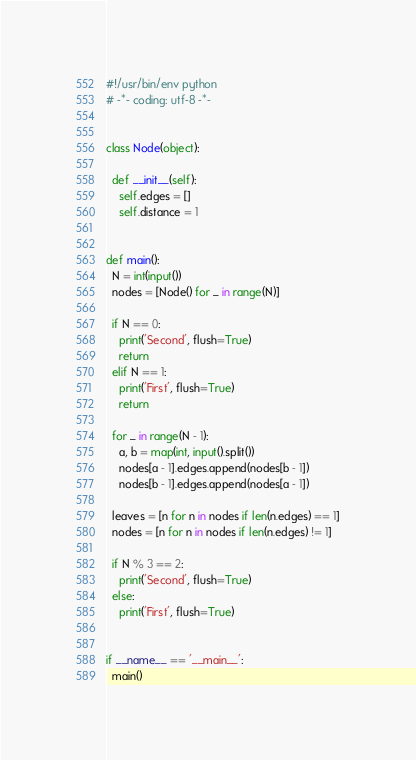Convert code to text. <code><loc_0><loc_0><loc_500><loc_500><_Python_>#!/usr/bin/env python
# -*- coding: utf-8 -*-


class Node(object):

  def __init__(self):
    self.edges = []
    self.distance = 1


def main():
  N = int(input())
  nodes = [Node() for _ in range(N)]

  if N == 0:
    print('Second', flush=True)
    return
  elif N == 1:
    print('First', flush=True)
    return

  for _ in range(N - 1):
    a, b = map(int, input().split())
    nodes[a - 1].edges.append(nodes[b - 1])
    nodes[b - 1].edges.append(nodes[a - 1])

  leaves = [n for n in nodes if len(n.edges) == 1]
  nodes = [n for n in nodes if len(n.edges) != 1]

  if N % 3 == 2:
    print('Second', flush=True)
  else:
    print('First', flush=True)


if __name__ == '__main__':
  main()

</code> 